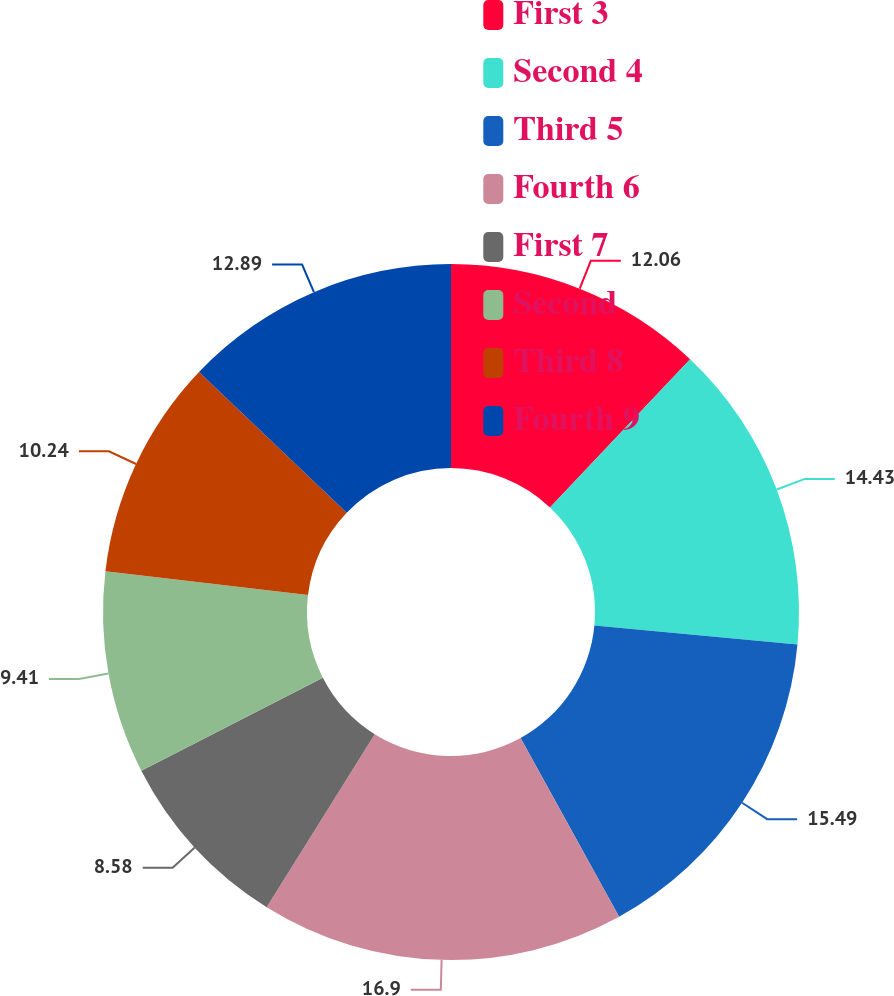Convert chart. <chart><loc_0><loc_0><loc_500><loc_500><pie_chart><fcel>First 3<fcel>Second 4<fcel>Third 5<fcel>Fourth 6<fcel>First 7<fcel>Second<fcel>Third 8<fcel>Fourth 9<nl><fcel>12.06%<fcel>14.43%<fcel>15.49%<fcel>16.91%<fcel>8.58%<fcel>9.41%<fcel>10.24%<fcel>12.89%<nl></chart> 